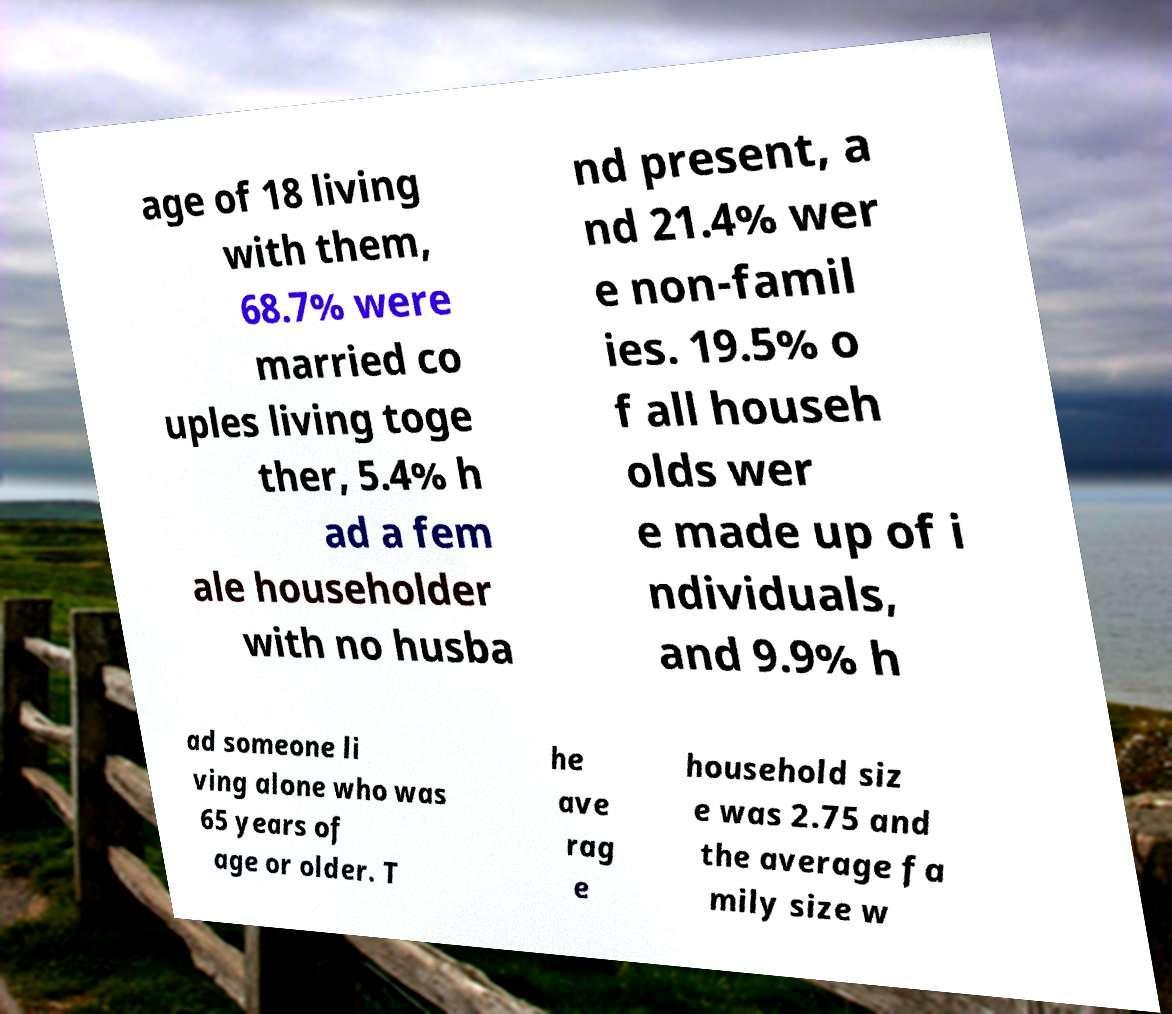What messages or text are displayed in this image? I need them in a readable, typed format. age of 18 living with them, 68.7% were married co uples living toge ther, 5.4% h ad a fem ale householder with no husba nd present, a nd 21.4% wer e non-famil ies. 19.5% o f all househ olds wer e made up of i ndividuals, and 9.9% h ad someone li ving alone who was 65 years of age or older. T he ave rag e household siz e was 2.75 and the average fa mily size w 